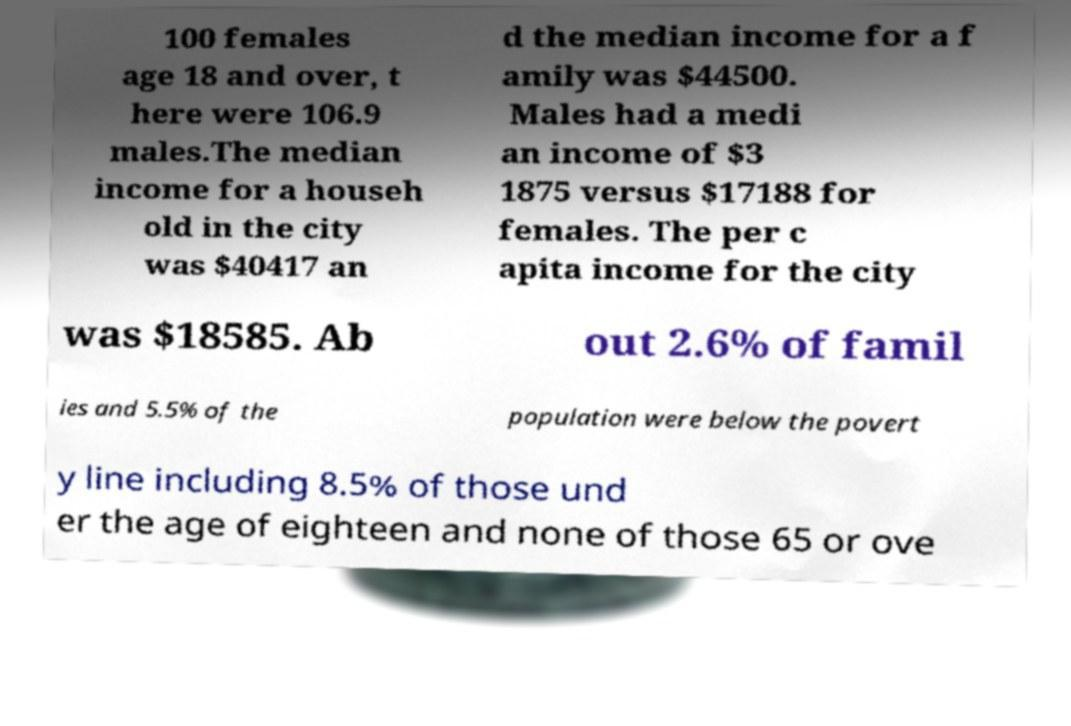What messages or text are displayed in this image? I need them in a readable, typed format. 100 females age 18 and over, t here were 106.9 males.The median income for a househ old in the city was $40417 an d the median income for a f amily was $44500. Males had a medi an income of $3 1875 versus $17188 for females. The per c apita income for the city was $18585. Ab out 2.6% of famil ies and 5.5% of the population were below the povert y line including 8.5% of those und er the age of eighteen and none of those 65 or ove 